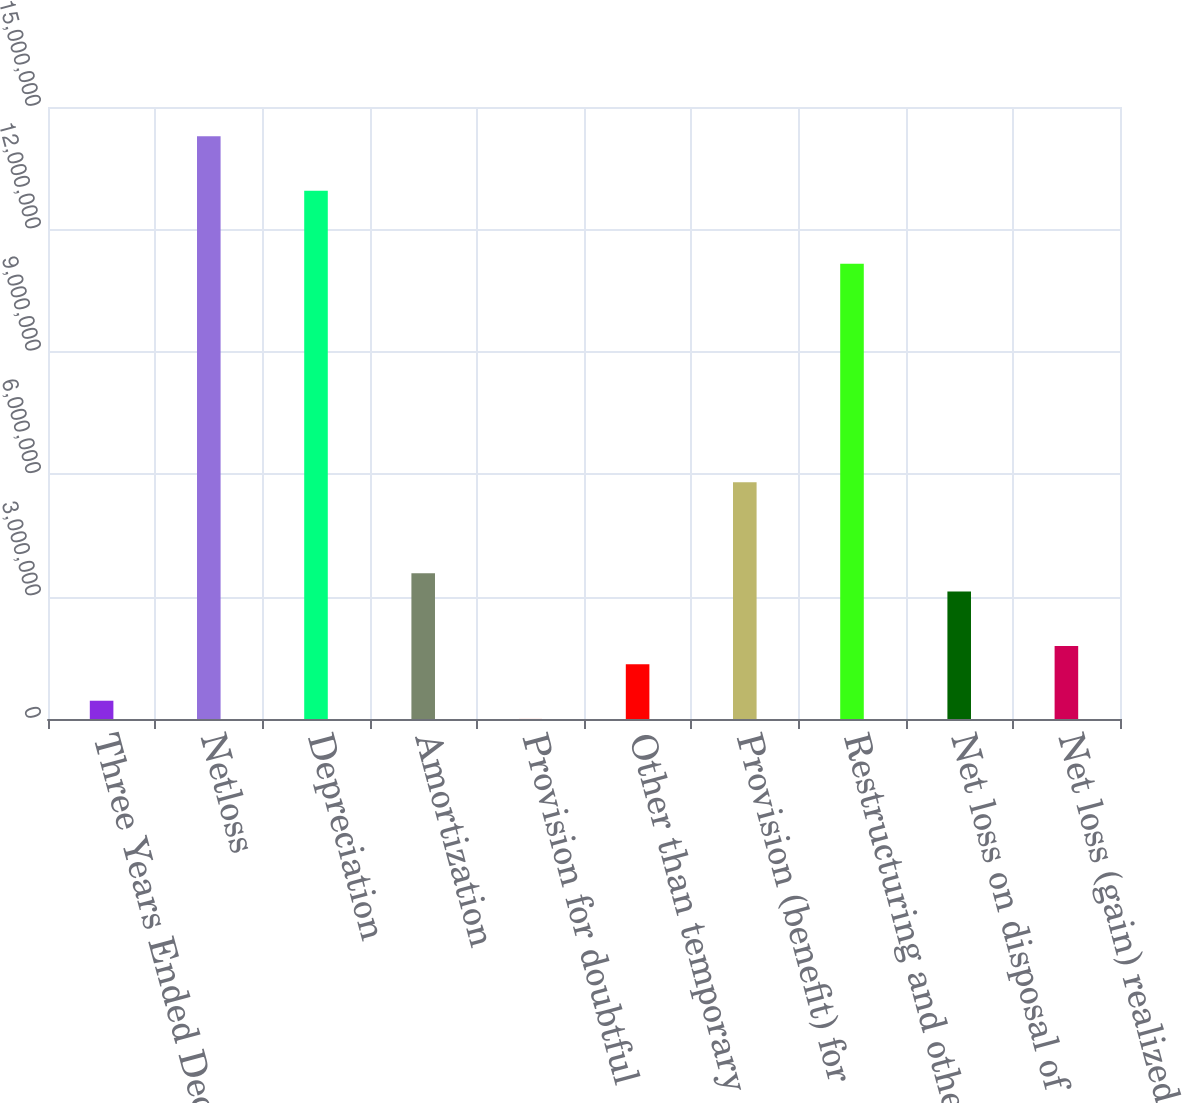Convert chart. <chart><loc_0><loc_0><loc_500><loc_500><bar_chart><fcel>Three Years Ended December 28<fcel>Netloss<fcel>Depreciation<fcel>Amortization<fcel>Provision for doubtful<fcel>Other than temporary<fcel>Provision (benefit) for<fcel>Restructuring and other<fcel>Net loss on disposal of<fcel>Net loss (gain) realized on<nl><fcel>447836<fcel>1.42856e+07<fcel>1.29465e+07<fcel>3.57249e+06<fcel>1456<fcel>1.34059e+06<fcel>5.80439e+06<fcel>1.11609e+07<fcel>3.12611e+06<fcel>1.78697e+06<nl></chart> 